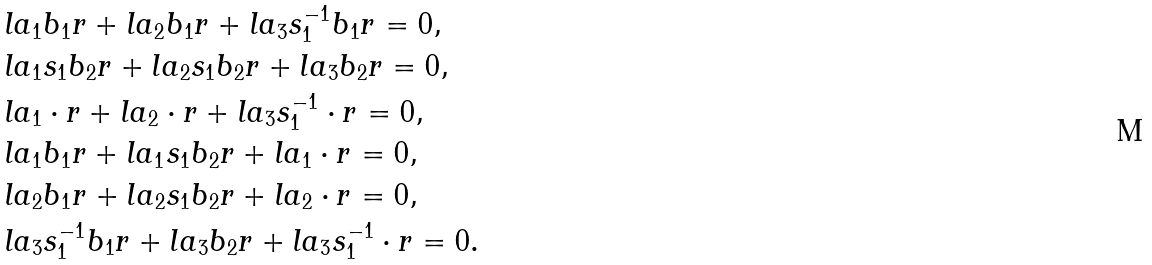Convert formula to latex. <formula><loc_0><loc_0><loc_500><loc_500>& l a _ { 1 } b _ { 1 } r + l a _ { 2 } b _ { 1 } r + l a _ { 3 } s _ { 1 } ^ { - 1 } b _ { 1 } r = 0 , \\ & l a _ { 1 } s _ { 1 } b _ { 2 } r + l a _ { 2 } s _ { 1 } b _ { 2 } r + l a _ { 3 } b _ { 2 } r = 0 , \\ & l a _ { 1 } \cdot r + l a _ { 2 } \cdot r + l a _ { 3 } s _ { 1 } ^ { - 1 } \cdot r = 0 , \\ & l a _ { 1 } b _ { 1 } r + l a _ { 1 } s _ { 1 } b _ { 2 } r + l a _ { 1 } \cdot r = 0 , \\ & l a _ { 2 } b _ { 1 } r + l a _ { 2 } s _ { 1 } b _ { 2 } r + l a _ { 2 } \cdot r = 0 , \\ & l a _ { 3 } s _ { 1 } ^ { - 1 } b _ { 1 } r + l a _ { 3 } b _ { 2 } r + l a _ { 3 } s _ { 1 } ^ { - 1 } \cdot r = 0 .</formula> 